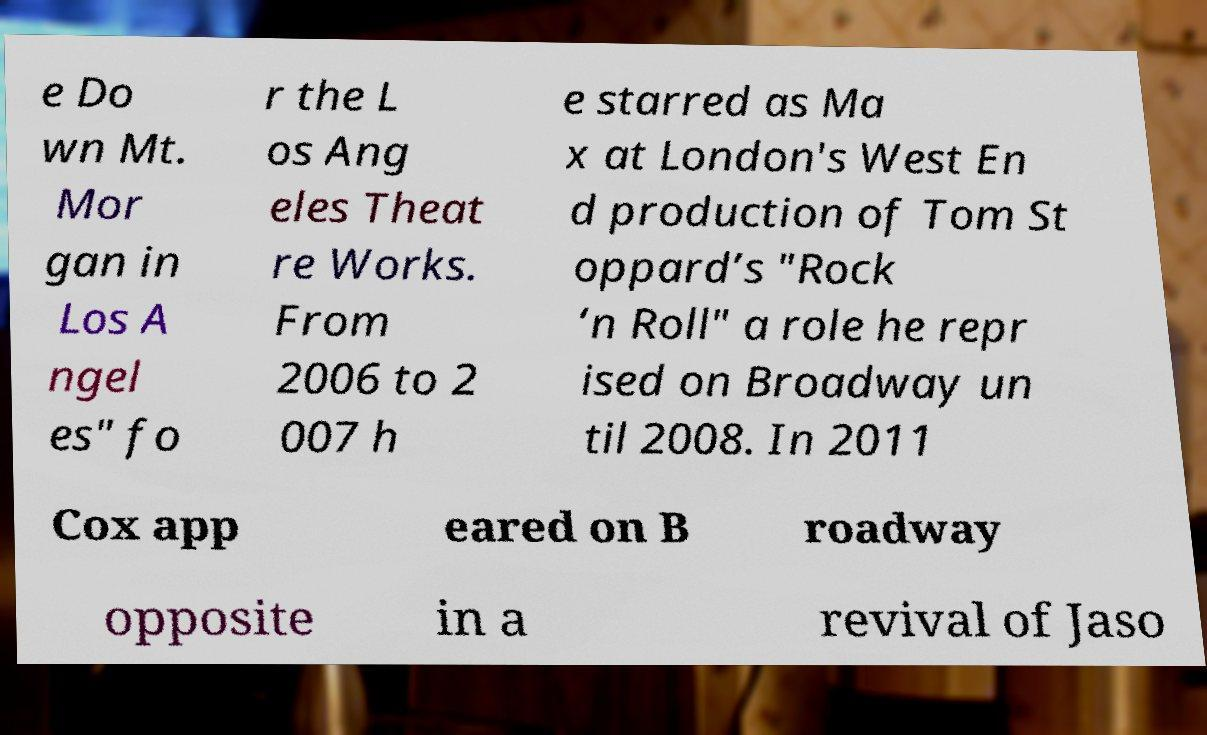For documentation purposes, I need the text within this image transcribed. Could you provide that? e Do wn Mt. Mor gan in Los A ngel es" fo r the L os Ang eles Theat re Works. From 2006 to 2 007 h e starred as Ma x at London's West En d production of Tom St oppard’s "Rock ‘n Roll" a role he repr ised on Broadway un til 2008. In 2011 Cox app eared on B roadway opposite in a revival of Jaso 